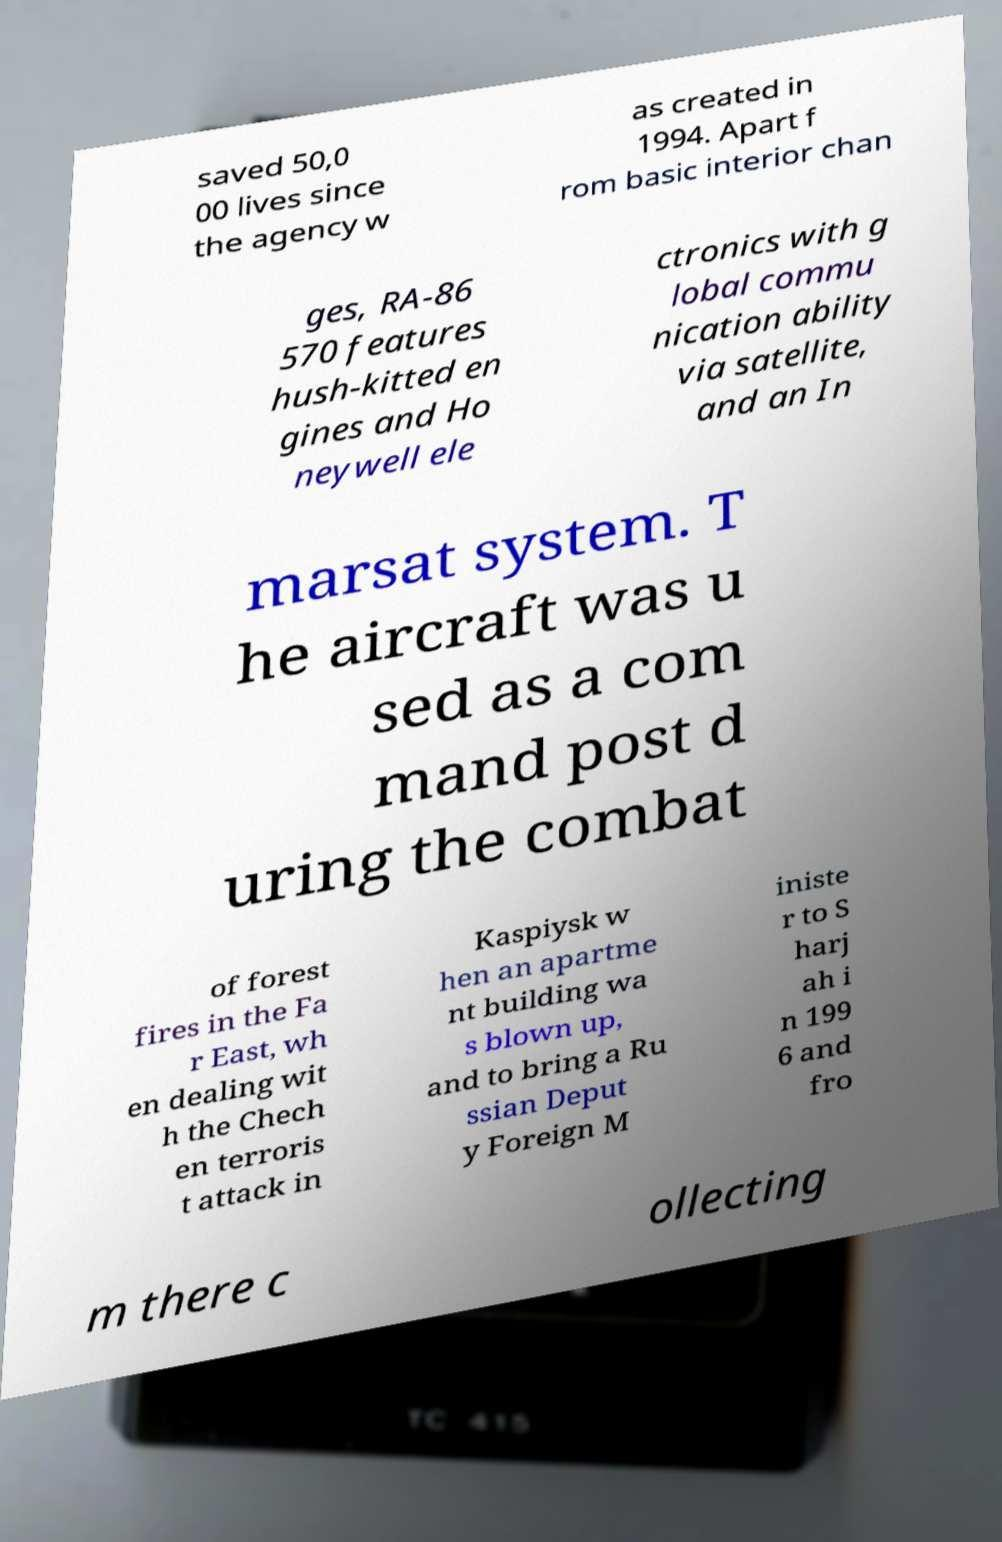Could you extract and type out the text from this image? saved 50,0 00 lives since the agency w as created in 1994. Apart f rom basic interior chan ges, RA-86 570 features hush-kitted en gines and Ho neywell ele ctronics with g lobal commu nication ability via satellite, and an In marsat system. T he aircraft was u sed as a com mand post d uring the combat of forest fires in the Fa r East, wh en dealing wit h the Chech en terroris t attack in Kaspiysk w hen an apartme nt building wa s blown up, and to bring a Ru ssian Deput y Foreign M iniste r to S harj ah i n 199 6 and fro m there c ollecting 